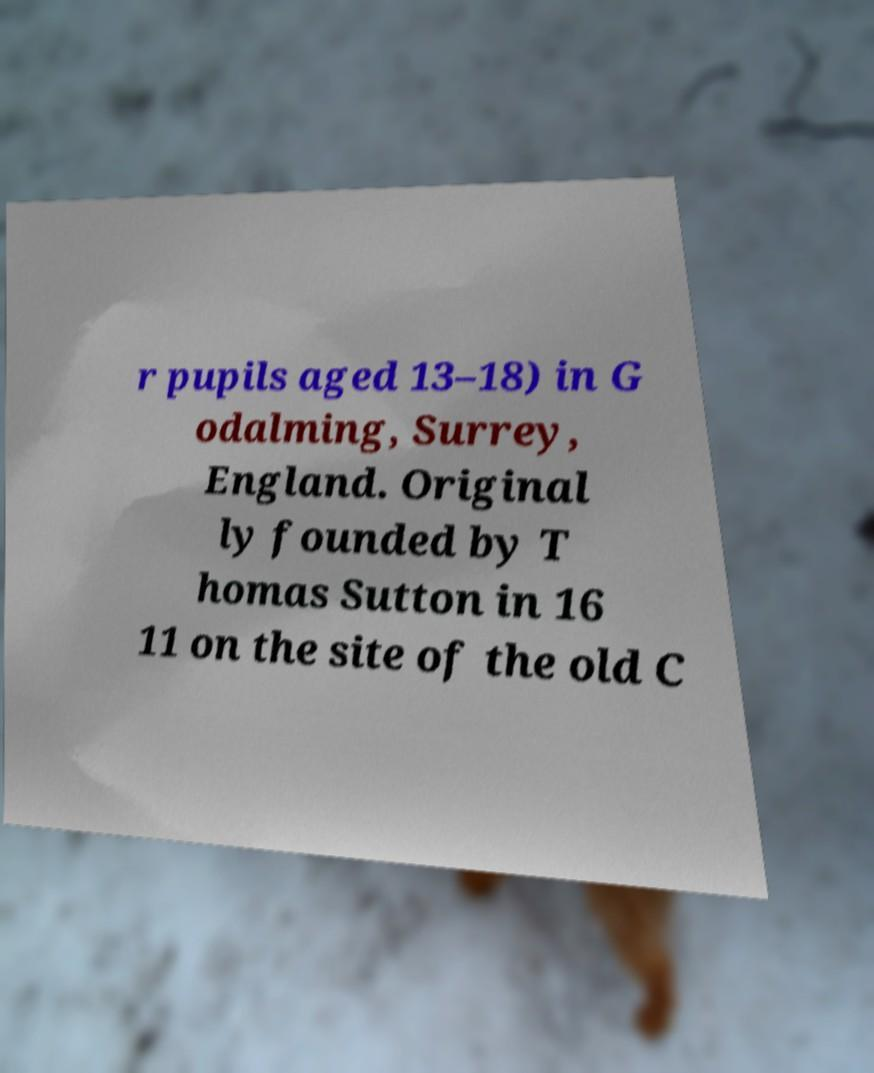Could you extract and type out the text from this image? r pupils aged 13–18) in G odalming, Surrey, England. Original ly founded by T homas Sutton in 16 11 on the site of the old C 